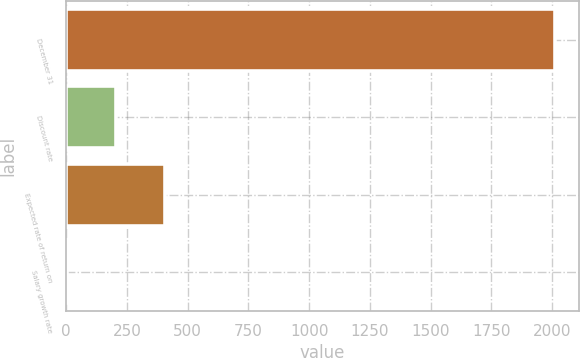<chart> <loc_0><loc_0><loc_500><loc_500><bar_chart><fcel>December 31<fcel>Discount rate<fcel>Expected rate of return on<fcel>Salary growth rate<nl><fcel>2011<fcel>205.15<fcel>405.8<fcel>4.5<nl></chart> 